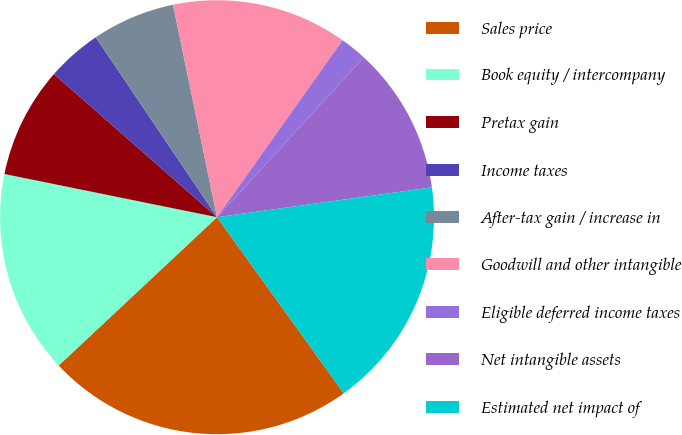Convert chart to OTSL. <chart><loc_0><loc_0><loc_500><loc_500><pie_chart><fcel>Sales price<fcel>Book equity / intercompany<fcel>Pretax gain<fcel>Income taxes<fcel>After-tax gain / increase in<fcel>Goodwill and other intangible<fcel>Eligible deferred income taxes<fcel>Net intangible assets<fcel>Estimated net impact of<nl><fcel>22.95%<fcel>15.17%<fcel>8.28%<fcel>4.09%<fcel>6.19%<fcel>13.07%<fcel>2.0%<fcel>10.98%<fcel>17.27%<nl></chart> 